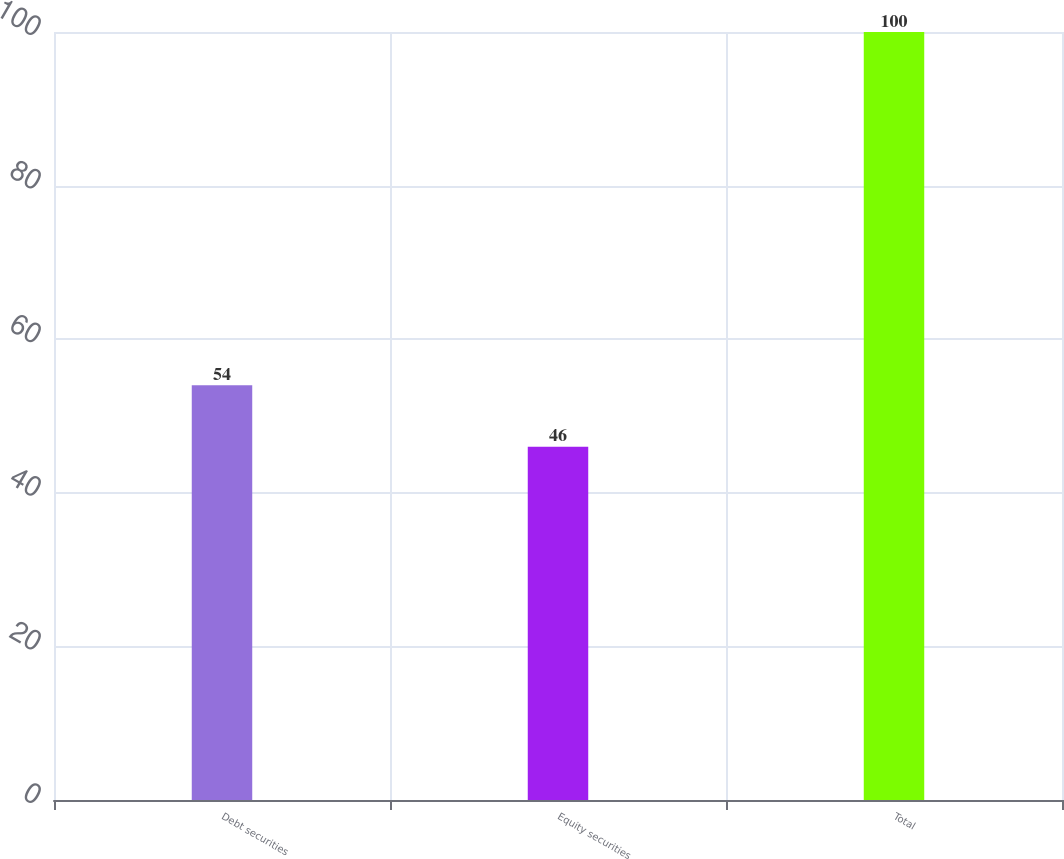<chart> <loc_0><loc_0><loc_500><loc_500><bar_chart><fcel>Debt securities<fcel>Equity securities<fcel>Total<nl><fcel>54<fcel>46<fcel>100<nl></chart> 